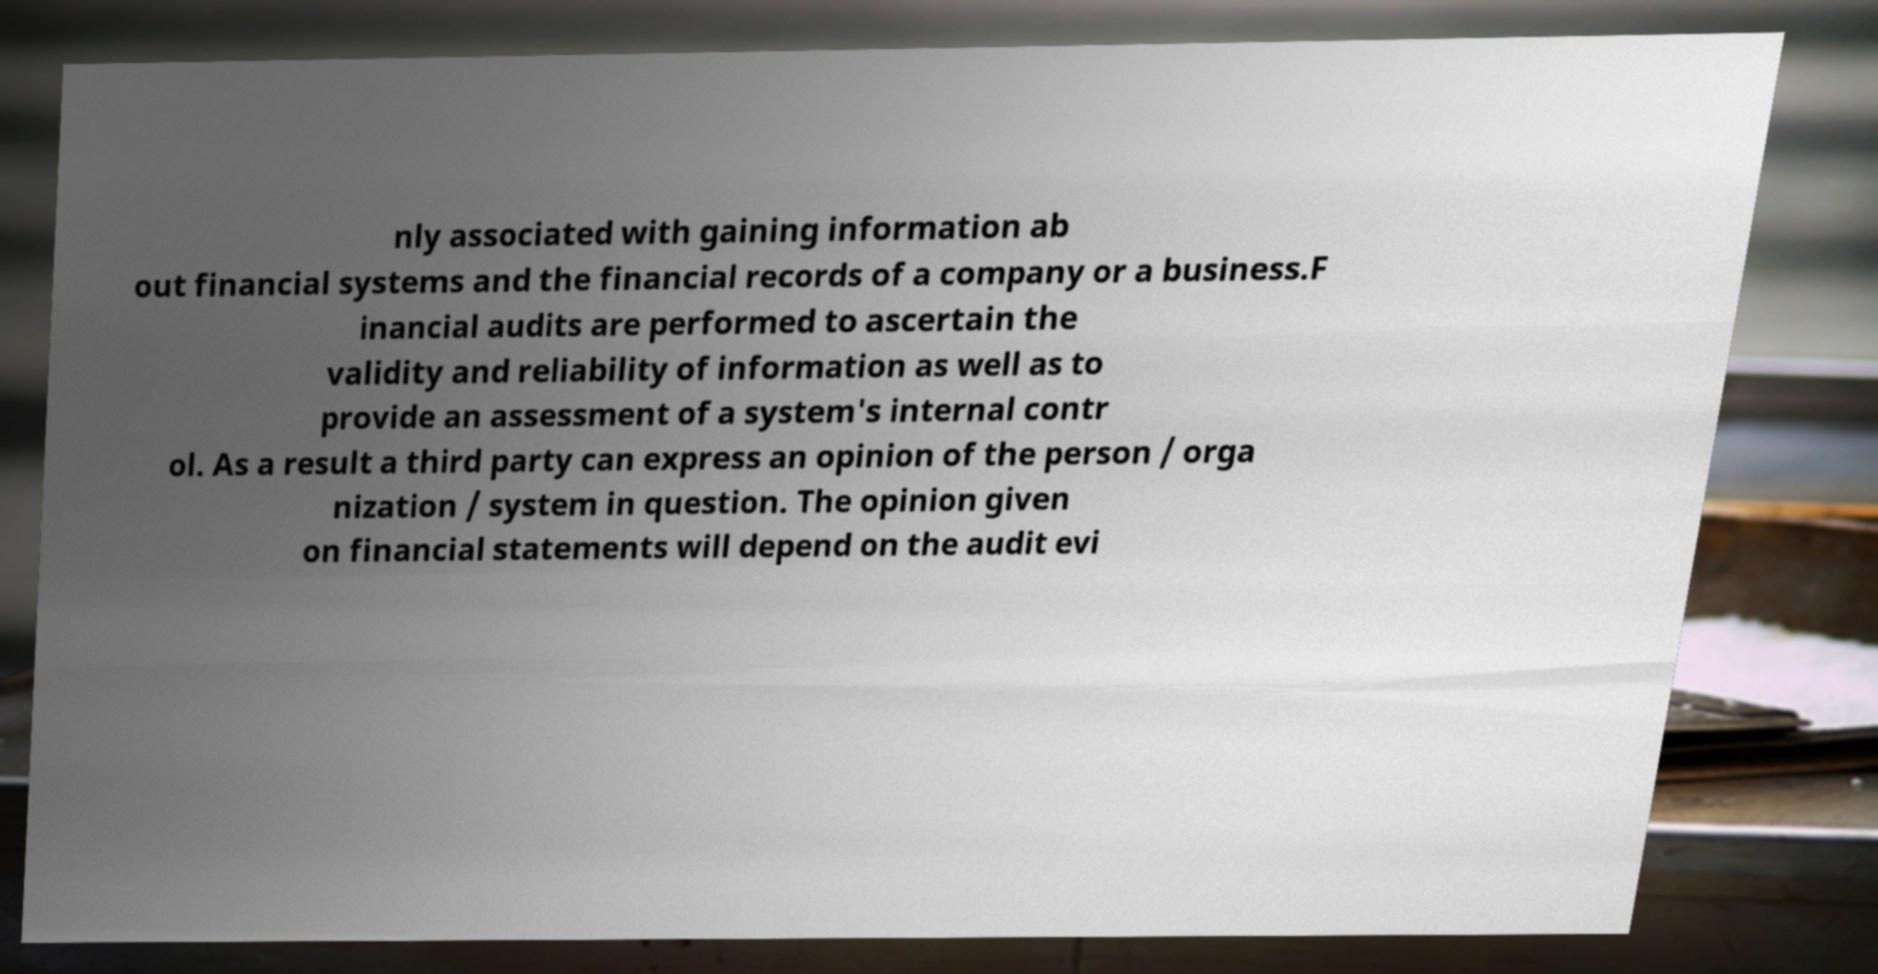For documentation purposes, I need the text within this image transcribed. Could you provide that? nly associated with gaining information ab out financial systems and the financial records of a company or a business.F inancial audits are performed to ascertain the validity and reliability of information as well as to provide an assessment of a system's internal contr ol. As a result a third party can express an opinion of the person / orga nization / system in question. The opinion given on financial statements will depend on the audit evi 